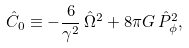<formula> <loc_0><loc_0><loc_500><loc_500>\hat { C } _ { 0 } \equiv - \frac { 6 } { \gamma ^ { 2 } } \, \hat { \Omega } ^ { 2 } + 8 \pi G \, \hat { P } ^ { 2 } _ { \phi } , \,</formula> 